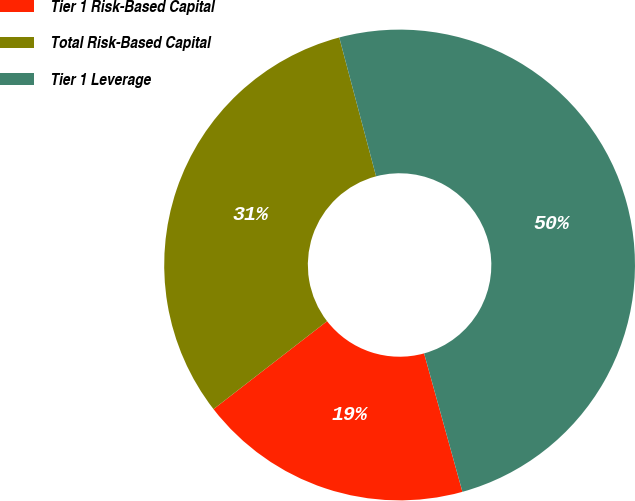<chart> <loc_0><loc_0><loc_500><loc_500><pie_chart><fcel>Tier 1 Risk-Based Capital<fcel>Total Risk-Based Capital<fcel>Tier 1 Leverage<nl><fcel>18.81%<fcel>31.36%<fcel>49.82%<nl></chart> 